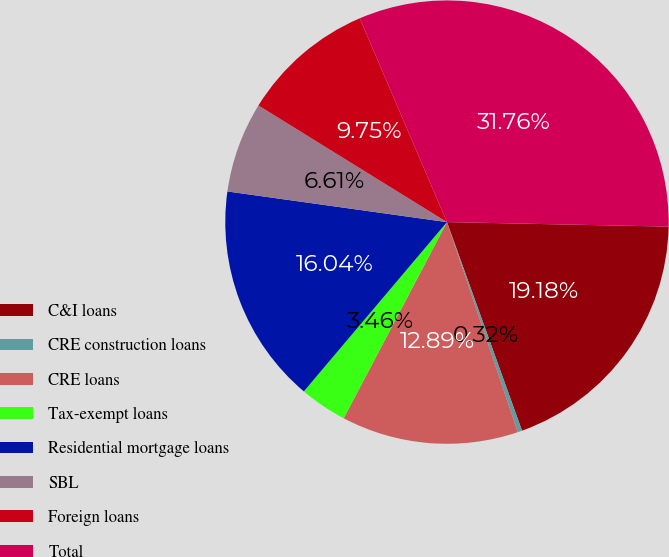Convert chart to OTSL. <chart><loc_0><loc_0><loc_500><loc_500><pie_chart><fcel>C&I loans<fcel>CRE construction loans<fcel>CRE loans<fcel>Tax-exempt loans<fcel>Residential mortgage loans<fcel>SBL<fcel>Foreign loans<fcel>Total<nl><fcel>19.18%<fcel>0.32%<fcel>12.89%<fcel>3.46%<fcel>16.04%<fcel>6.61%<fcel>9.75%<fcel>31.76%<nl></chart> 